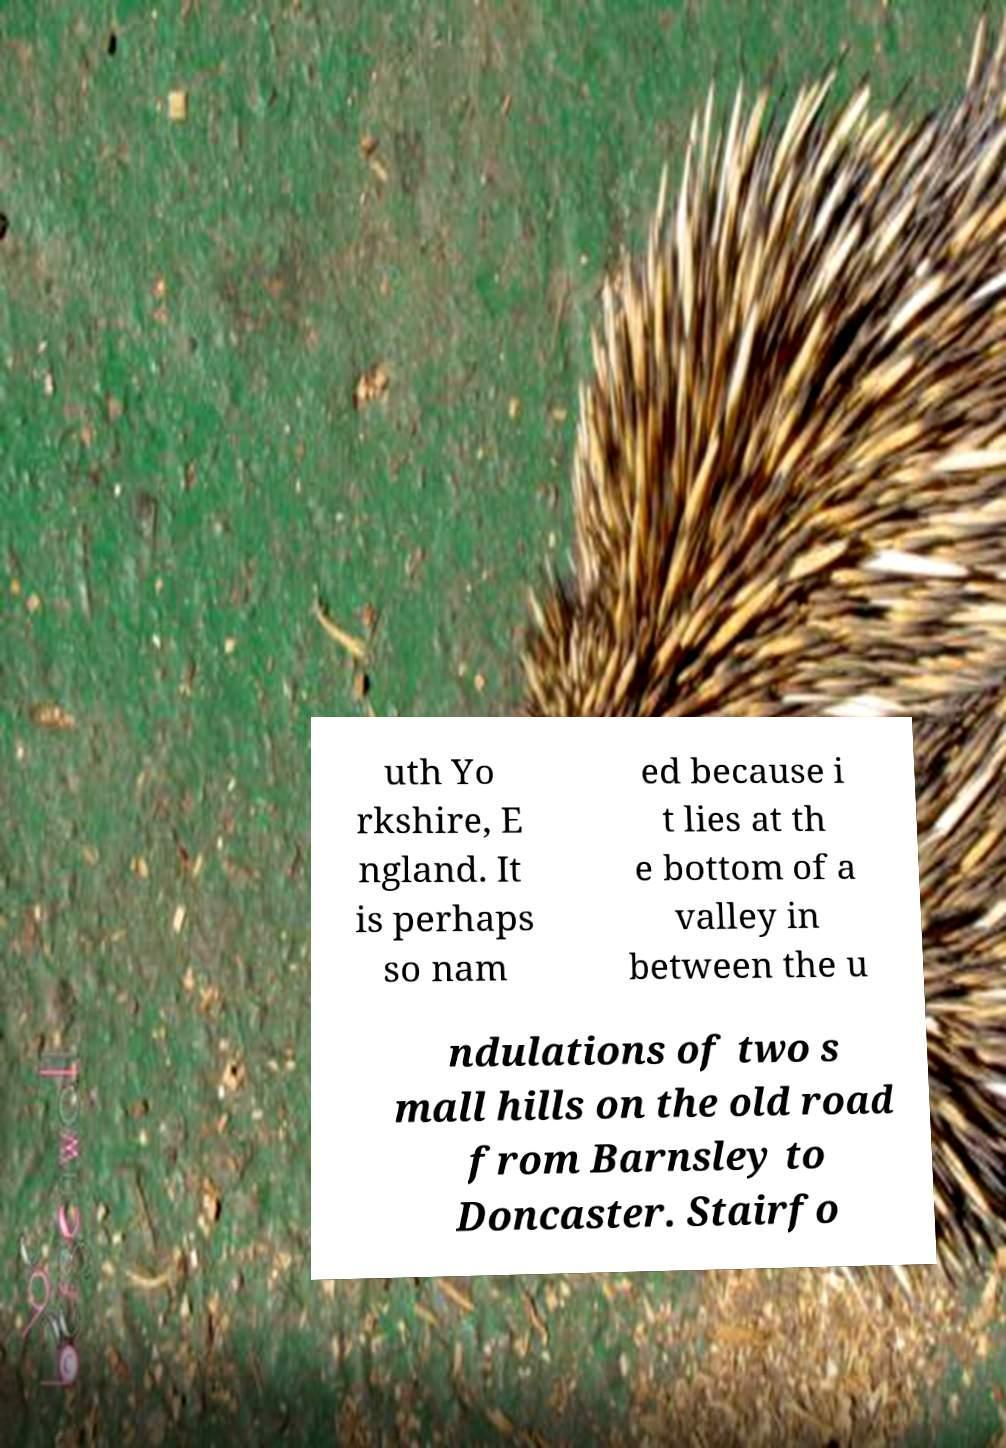Can you read and provide the text displayed in the image?This photo seems to have some interesting text. Can you extract and type it out for me? uth Yo rkshire, E ngland. It is perhaps so nam ed because i t lies at th e bottom of a valley in between the u ndulations of two s mall hills on the old road from Barnsley to Doncaster. Stairfo 